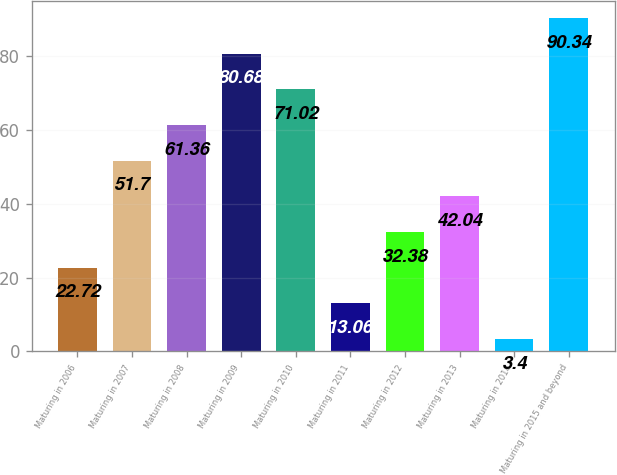Convert chart. <chart><loc_0><loc_0><loc_500><loc_500><bar_chart><fcel>Maturing in 2006<fcel>Maturing in 2007<fcel>Maturing in 2008<fcel>Maturing in 2009<fcel>Maturing in 2010<fcel>Maturing in 2011<fcel>Maturing in 2012<fcel>Maturing in 2013<fcel>Maturing in 2014<fcel>Maturing in 2015 and beyond<nl><fcel>22.72<fcel>51.7<fcel>61.36<fcel>80.68<fcel>71.02<fcel>13.06<fcel>32.38<fcel>42.04<fcel>3.4<fcel>90.34<nl></chart> 